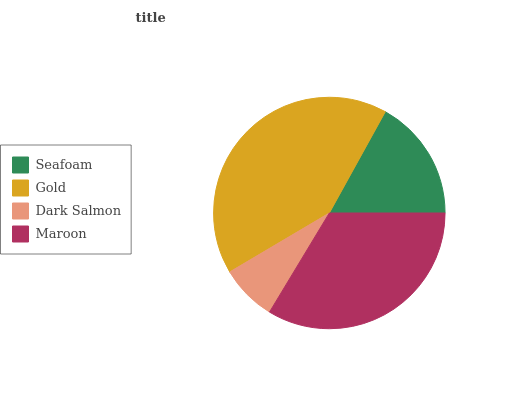Is Dark Salmon the minimum?
Answer yes or no. Yes. Is Gold the maximum?
Answer yes or no. Yes. Is Gold the minimum?
Answer yes or no. No. Is Dark Salmon the maximum?
Answer yes or no. No. Is Gold greater than Dark Salmon?
Answer yes or no. Yes. Is Dark Salmon less than Gold?
Answer yes or no. Yes. Is Dark Salmon greater than Gold?
Answer yes or no. No. Is Gold less than Dark Salmon?
Answer yes or no. No. Is Maroon the high median?
Answer yes or no. Yes. Is Seafoam the low median?
Answer yes or no. Yes. Is Seafoam the high median?
Answer yes or no. No. Is Maroon the low median?
Answer yes or no. No. 